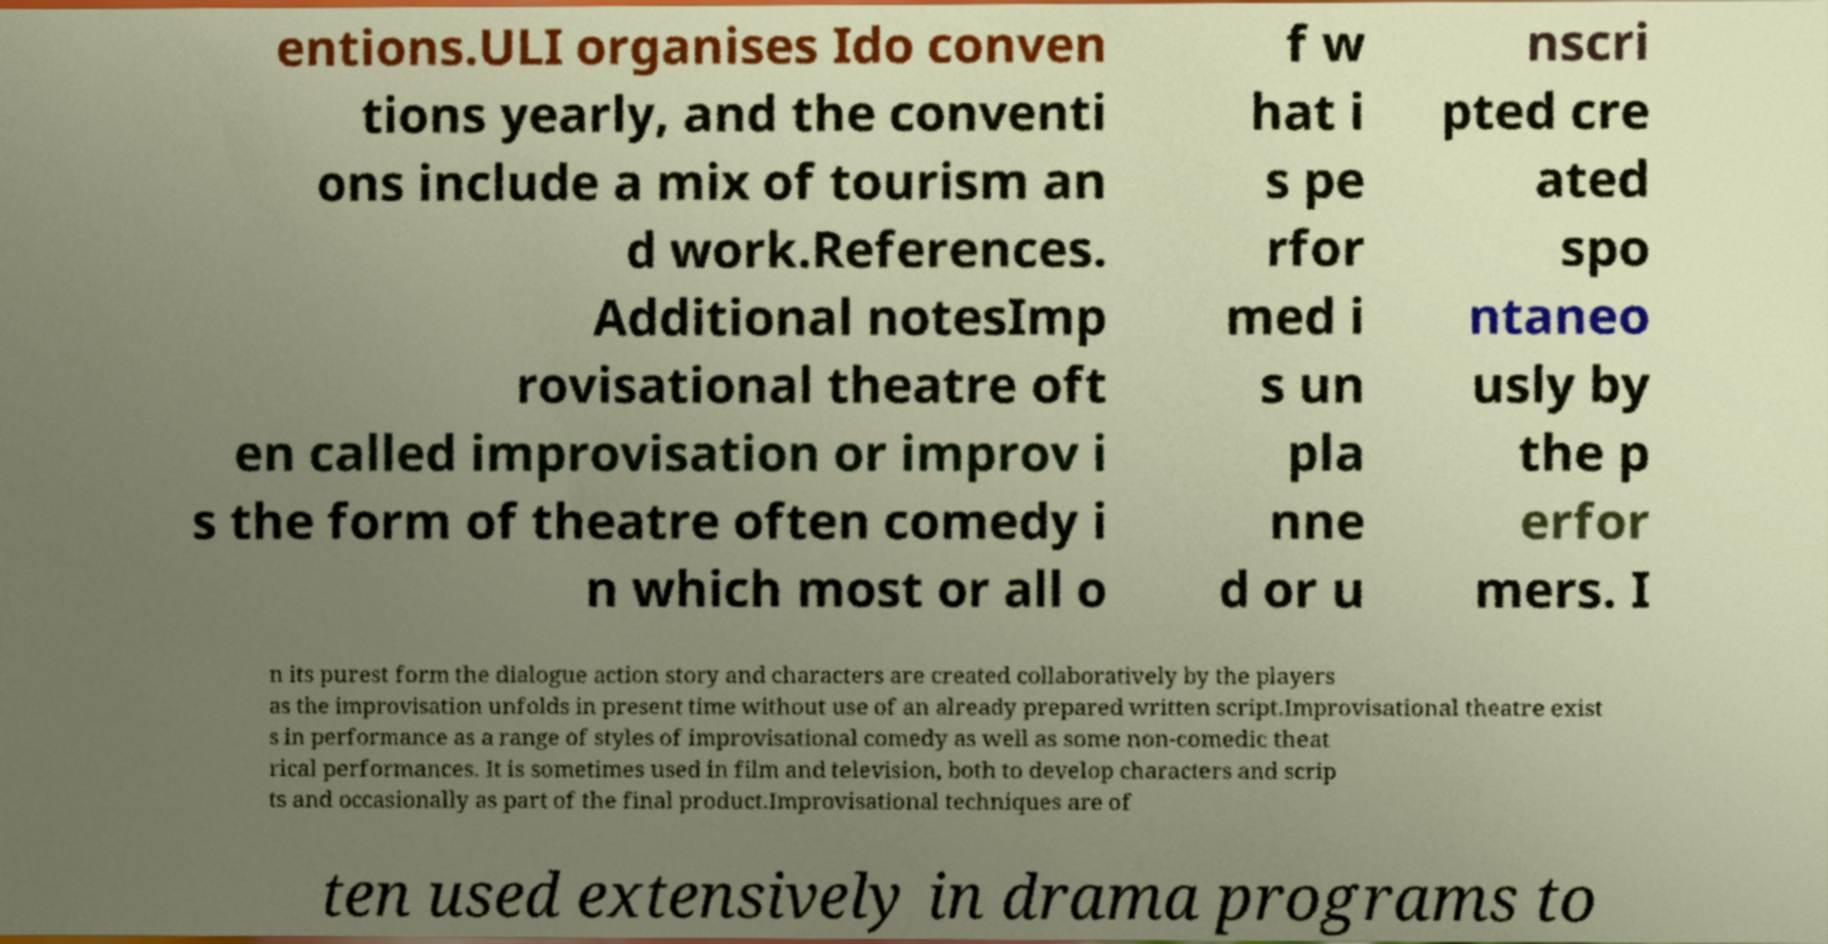Please identify and transcribe the text found in this image. entions.ULI organises Ido conven tions yearly, and the conventi ons include a mix of tourism an d work.References. Additional notesImp rovisational theatre oft en called improvisation or improv i s the form of theatre often comedy i n which most or all o f w hat i s pe rfor med i s un pla nne d or u nscri pted cre ated spo ntaneo usly by the p erfor mers. I n its purest form the dialogue action story and characters are created collaboratively by the players as the improvisation unfolds in present time without use of an already prepared written script.Improvisational theatre exist s in performance as a range of styles of improvisational comedy as well as some non-comedic theat rical performances. It is sometimes used in film and television, both to develop characters and scrip ts and occasionally as part of the final product.Improvisational techniques are of ten used extensively in drama programs to 